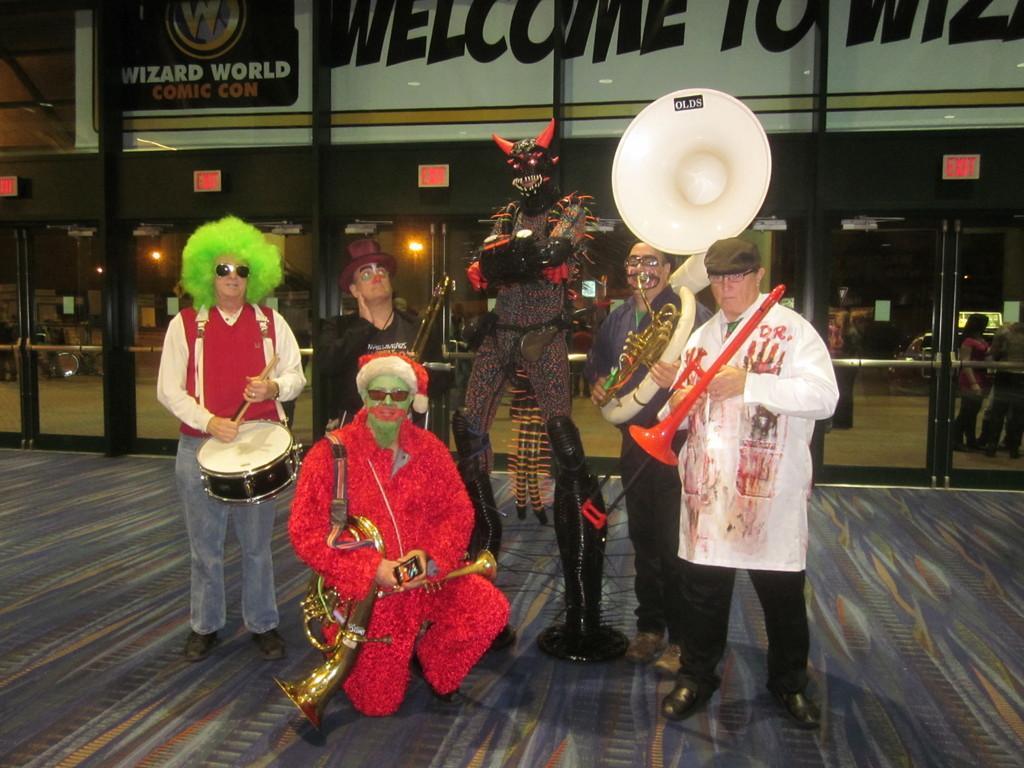Could you give a brief overview of what you see in this image? In the foreground, I can see a group of people are playing musical instruments on the floor. In the background, I can see a building, board, metal rods, lights and a group of people. This picture might be taken during night. 